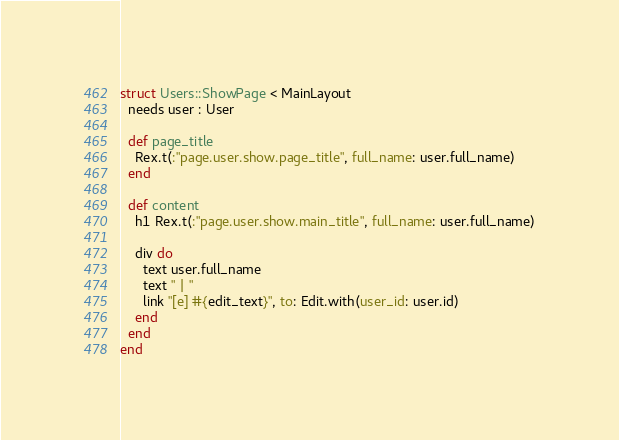Convert code to text. <code><loc_0><loc_0><loc_500><loc_500><_Crystal_>struct Users::ShowPage < MainLayout
  needs user : User

  def page_title
    Rex.t(:"page.user.show.page_title", full_name: user.full_name)
  end

  def content
    h1 Rex.t(:"page.user.show.main_title", full_name: user.full_name)

    div do
      text user.full_name
      text " | "
      link "[e] #{edit_text}", to: Edit.with(user_id: user.id)
    end
  end
end
</code> 